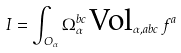<formula> <loc_0><loc_0><loc_500><loc_500>I = \int _ { O _ { \alpha } } \Omega _ { \alpha } ^ { b c } \, \text {Vol} _ { \alpha , a b c } \, f ^ { a }</formula> 